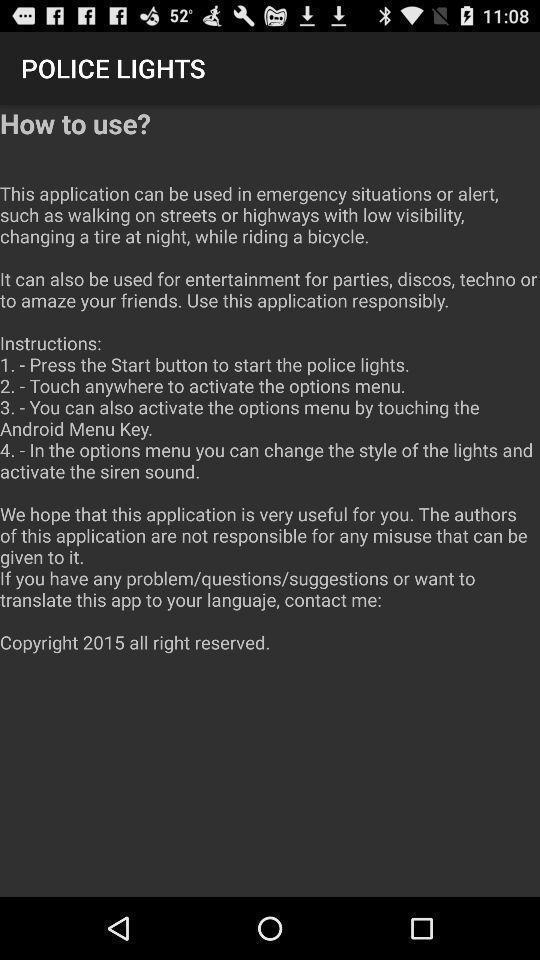Tell me about the visual elements in this screen capture. Page showing instructions for using the police lights. 